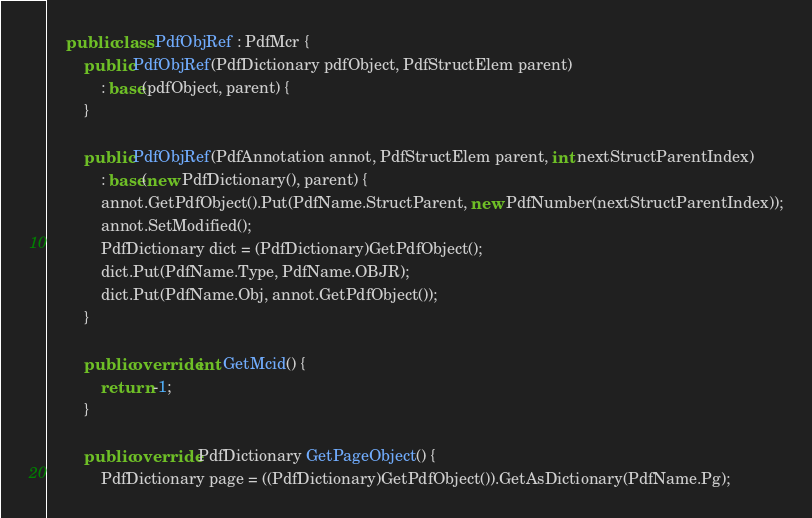<code> <loc_0><loc_0><loc_500><loc_500><_C#_>    public class PdfObjRef : PdfMcr {
        public PdfObjRef(PdfDictionary pdfObject, PdfStructElem parent)
            : base(pdfObject, parent) {
        }

        public PdfObjRef(PdfAnnotation annot, PdfStructElem parent, int nextStructParentIndex)
            : base(new PdfDictionary(), parent) {
            annot.GetPdfObject().Put(PdfName.StructParent, new PdfNumber(nextStructParentIndex));
            annot.SetModified();
            PdfDictionary dict = (PdfDictionary)GetPdfObject();
            dict.Put(PdfName.Type, PdfName.OBJR);
            dict.Put(PdfName.Obj, annot.GetPdfObject());
        }

        public override int GetMcid() {
            return -1;
        }

        public override PdfDictionary GetPageObject() {
            PdfDictionary page = ((PdfDictionary)GetPdfObject()).GetAsDictionary(PdfName.Pg);</code> 